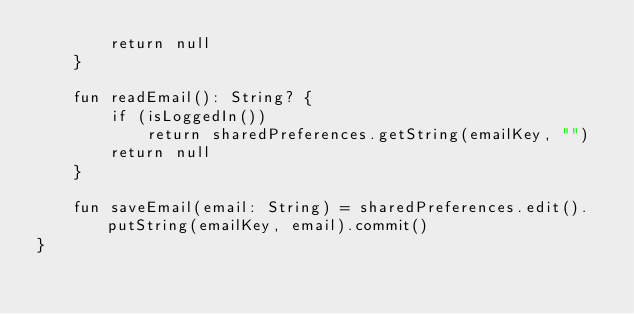<code> <loc_0><loc_0><loc_500><loc_500><_Kotlin_>        return null
    }

    fun readEmail(): String? {
        if (isLoggedIn())
            return sharedPreferences.getString(emailKey, "")
        return null
    }

    fun saveEmail(email: String) = sharedPreferences.edit().putString(emailKey, email).commit()
}</code> 